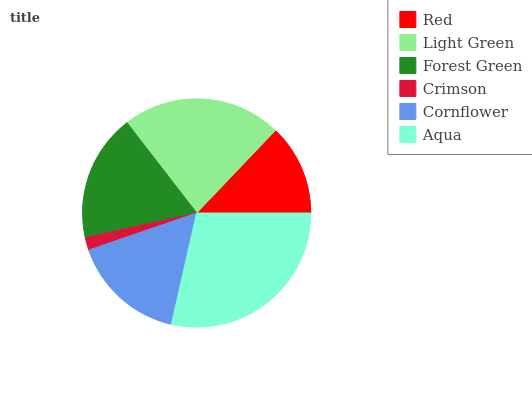Is Crimson the minimum?
Answer yes or no. Yes. Is Aqua the maximum?
Answer yes or no. Yes. Is Light Green the minimum?
Answer yes or no. No. Is Light Green the maximum?
Answer yes or no. No. Is Light Green greater than Red?
Answer yes or no. Yes. Is Red less than Light Green?
Answer yes or no. Yes. Is Red greater than Light Green?
Answer yes or no. No. Is Light Green less than Red?
Answer yes or no. No. Is Forest Green the high median?
Answer yes or no. Yes. Is Cornflower the low median?
Answer yes or no. Yes. Is Aqua the high median?
Answer yes or no. No. Is Light Green the low median?
Answer yes or no. No. 